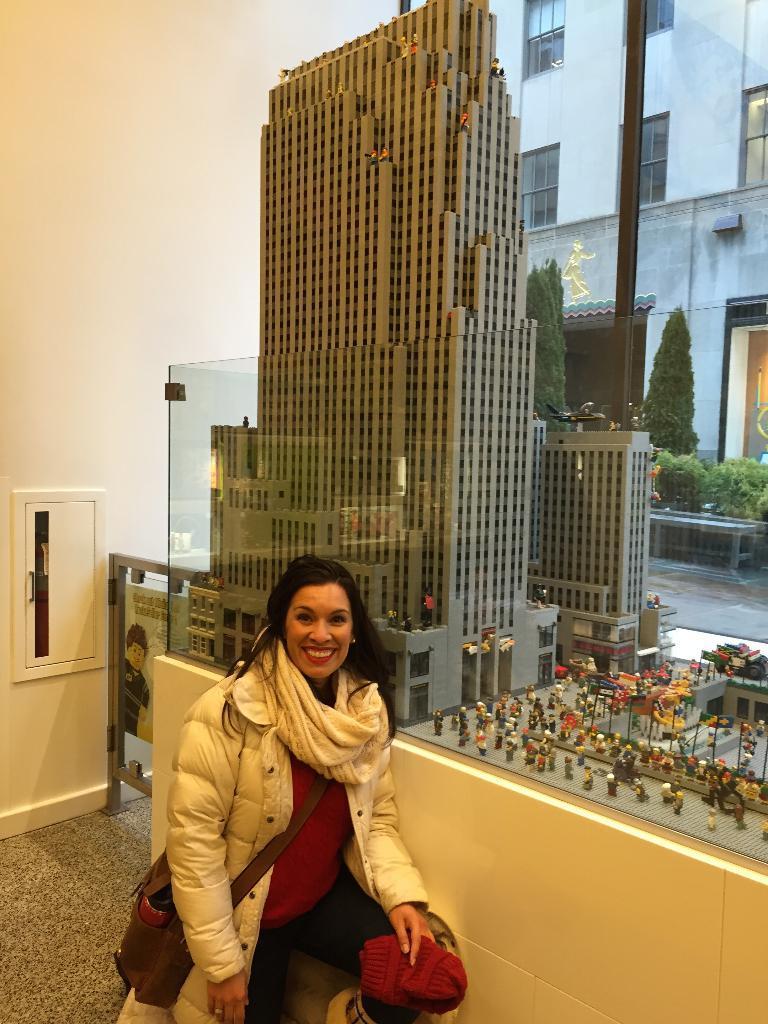How would you summarize this image in a sentence or two? In this image we can see a woman is in crouch position on the floor and carrying a bag on her shoulder, wall and a door. we can see design of a building an objects are on a platform placed in a glass box. In the background we can see building, windows, trees, plants and a pole. 